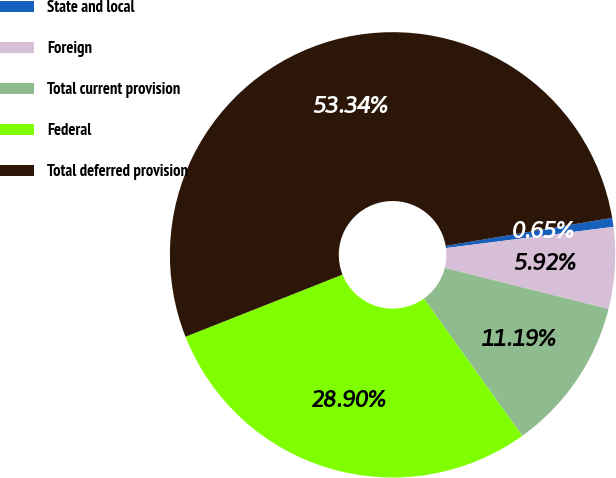Convert chart. <chart><loc_0><loc_0><loc_500><loc_500><pie_chart><fcel>State and local<fcel>Foreign<fcel>Total current provision<fcel>Federal<fcel>Total deferred provision<nl><fcel>0.65%<fcel>5.92%<fcel>11.19%<fcel>28.9%<fcel>53.34%<nl></chart> 